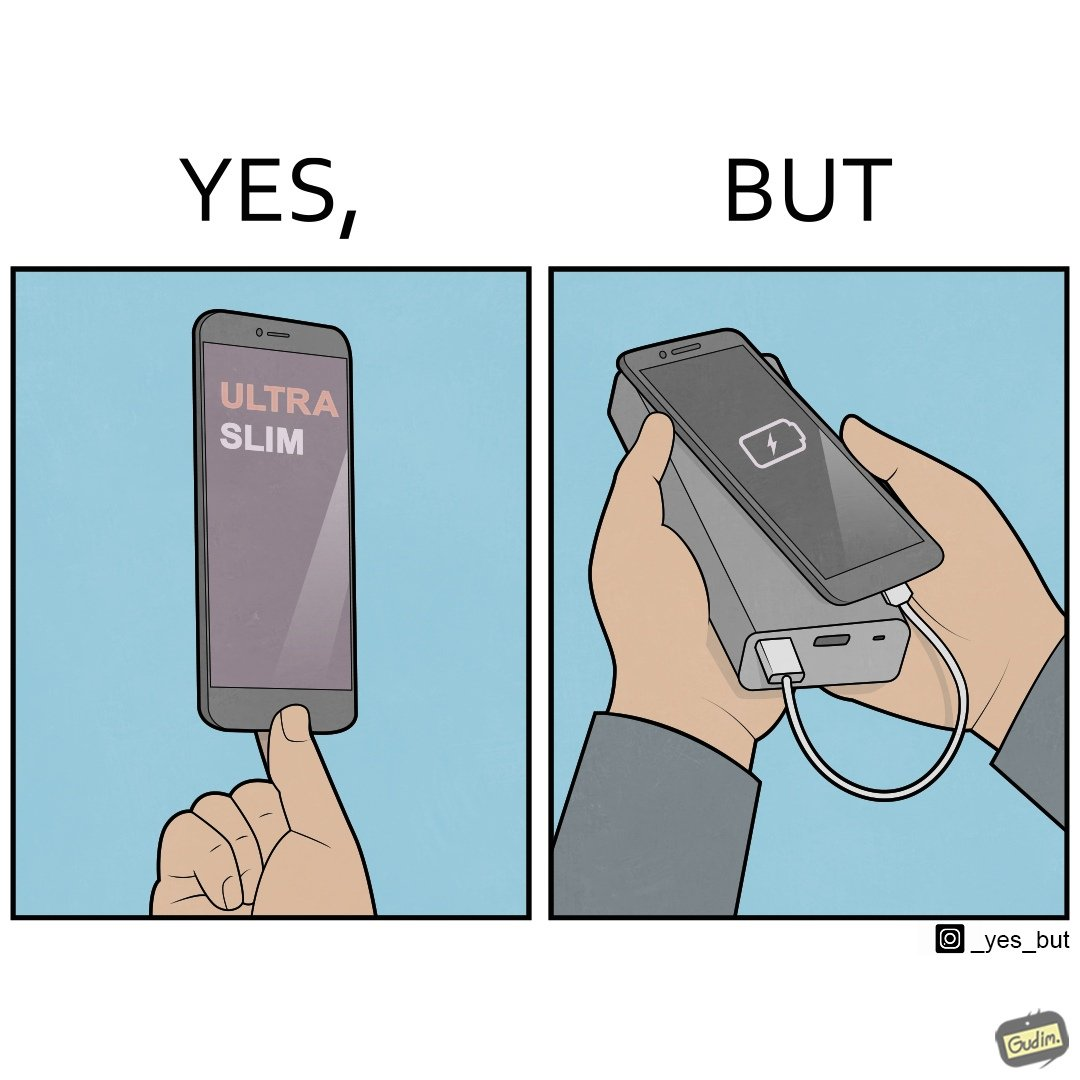What is shown in the left half versus the right half of this image? In the left part of the image: The image shows a hand holding a mobile phone with finger tips. The text on the screen of the mobile phone says "ULTRA SLIM".  The mobile phone is indeed very slim. In the right part of the image: The image shows a slim mobile phone connected to a thick,big and heavy power bank for charging the mobile phone. 